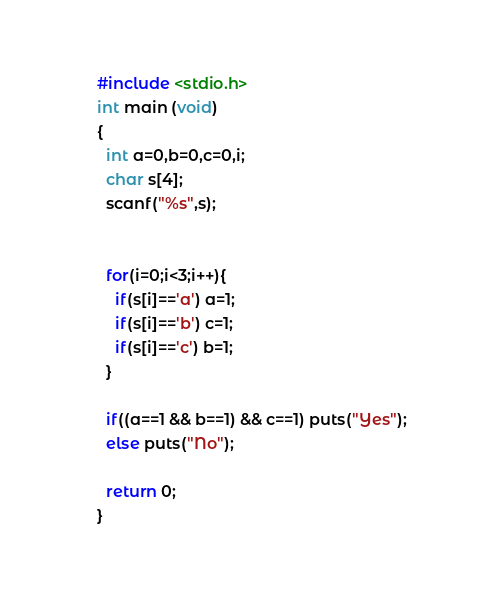Convert code to text. <code><loc_0><loc_0><loc_500><loc_500><_C_>#include <stdio.h>
int main (void)
{
  int a=0,b=0,c=0,i;
  char s[4];
  scanf("%s",s);


  for(i=0;i<3;i++){
    if(s[i]=='a') a=1;
    if(s[i]=='b') c=1;
    if(s[i]=='c') b=1;
  }

  if((a==1 && b==1) && c==1) puts("Yes");
  else puts("No");

  return 0;
}
</code> 